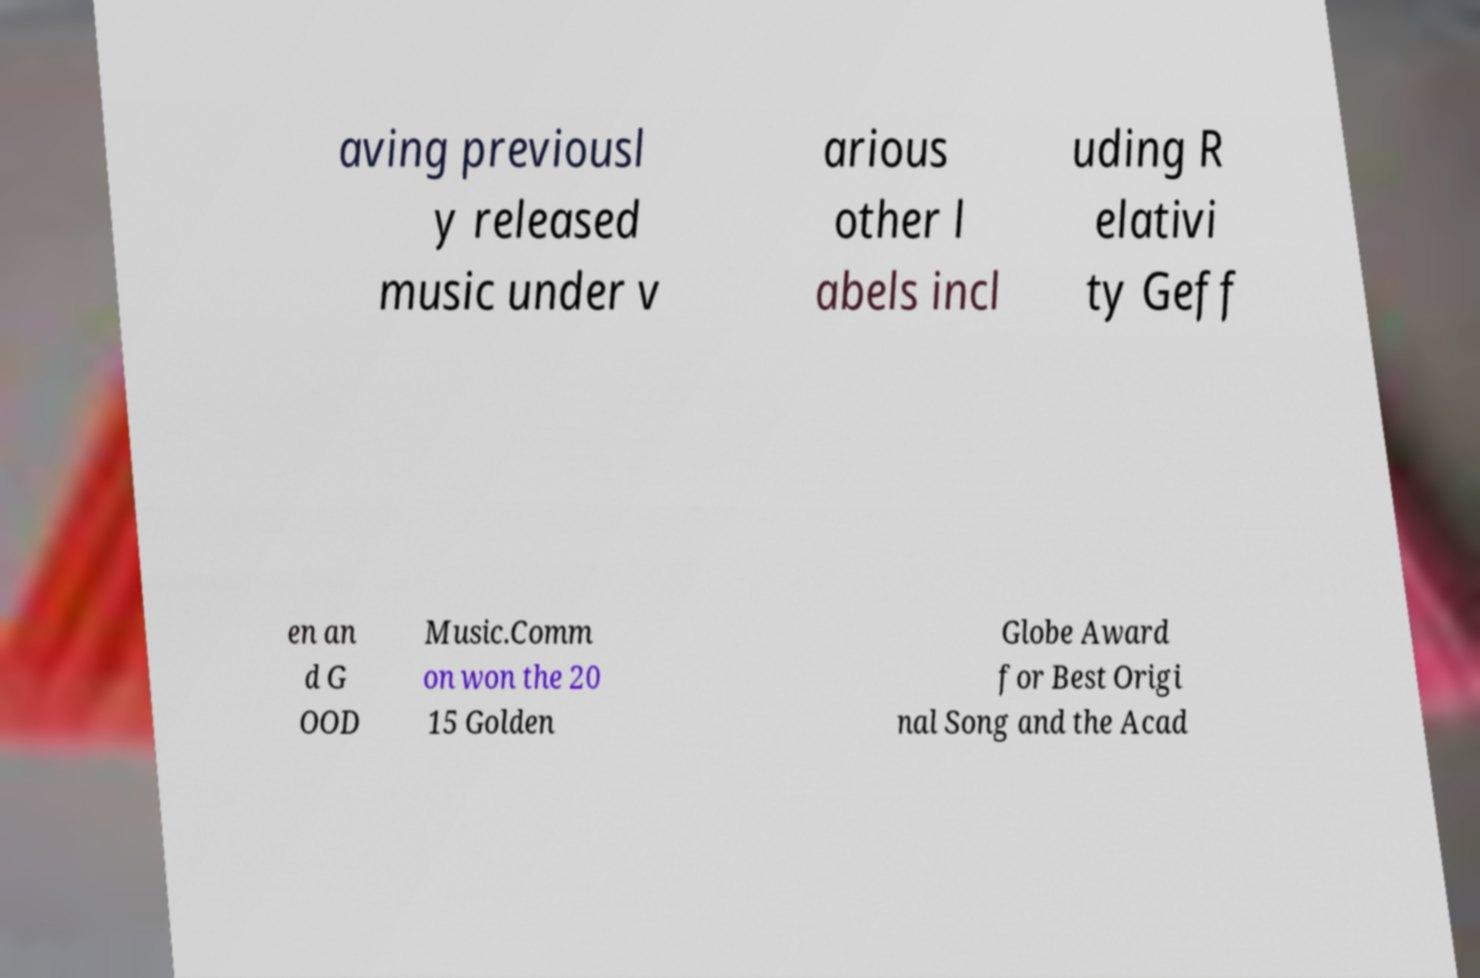Please identify and transcribe the text found in this image. aving previousl y released music under v arious other l abels incl uding R elativi ty Geff en an d G OOD Music.Comm on won the 20 15 Golden Globe Award for Best Origi nal Song and the Acad 